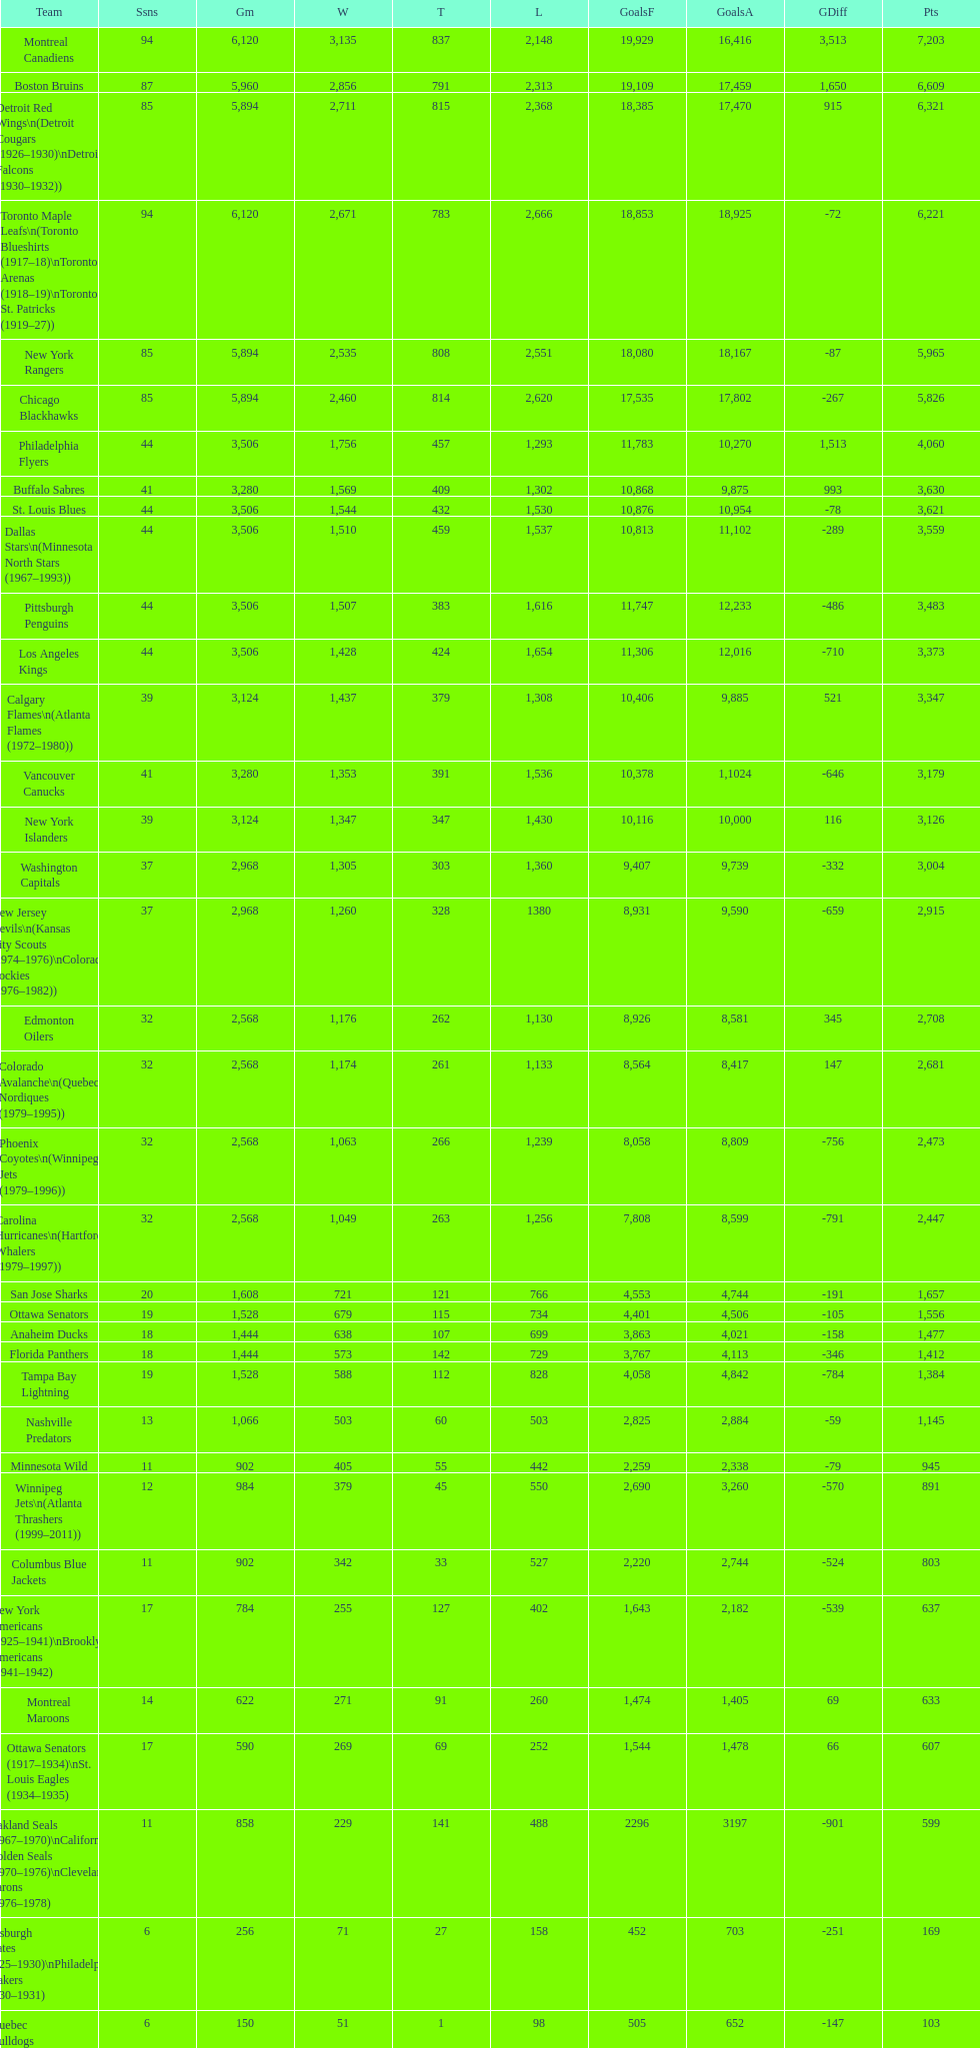How many losses do the st. louis blues have? 1,530. 